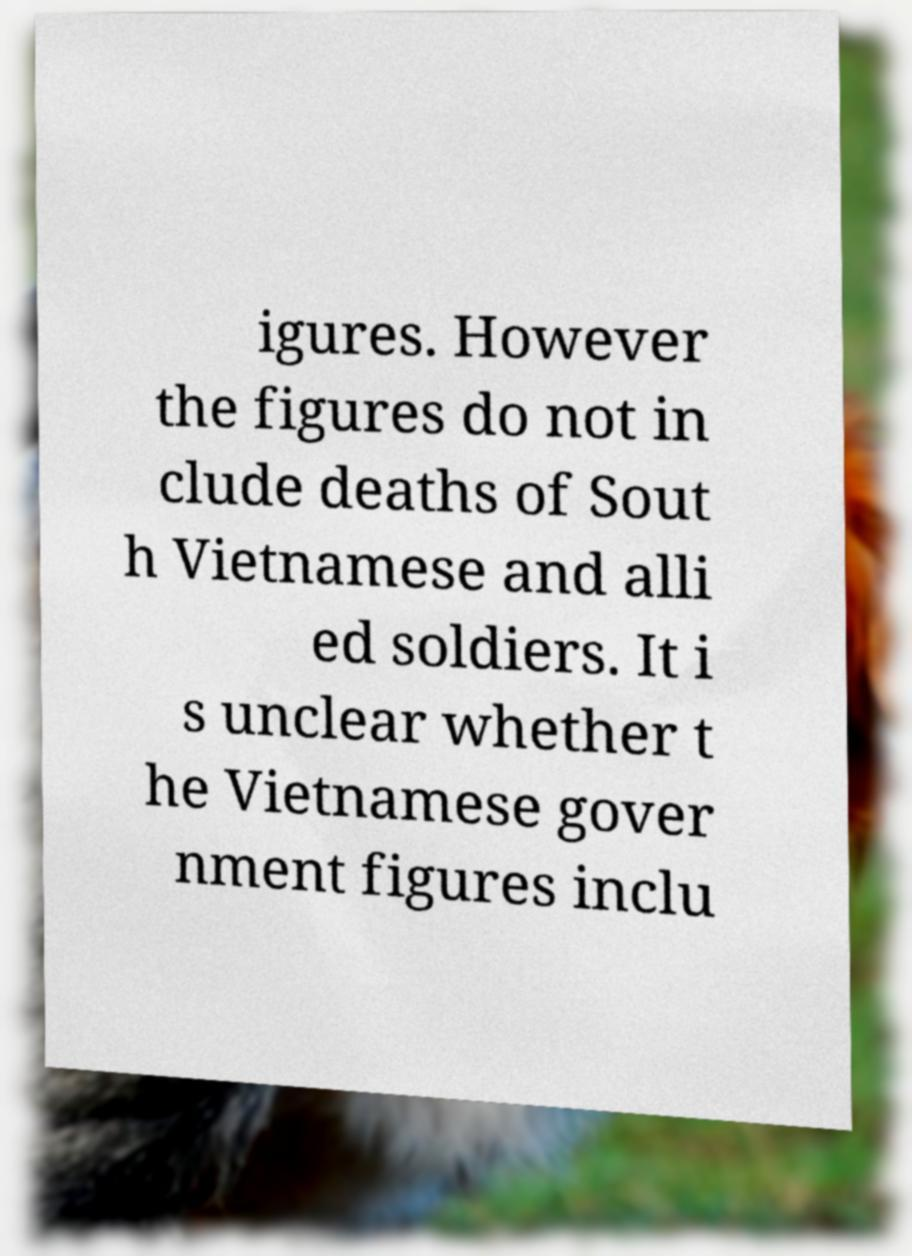Please identify and transcribe the text found in this image. igures. However the figures do not in clude deaths of Sout h Vietnamese and alli ed soldiers. It i s unclear whether t he Vietnamese gover nment figures inclu 